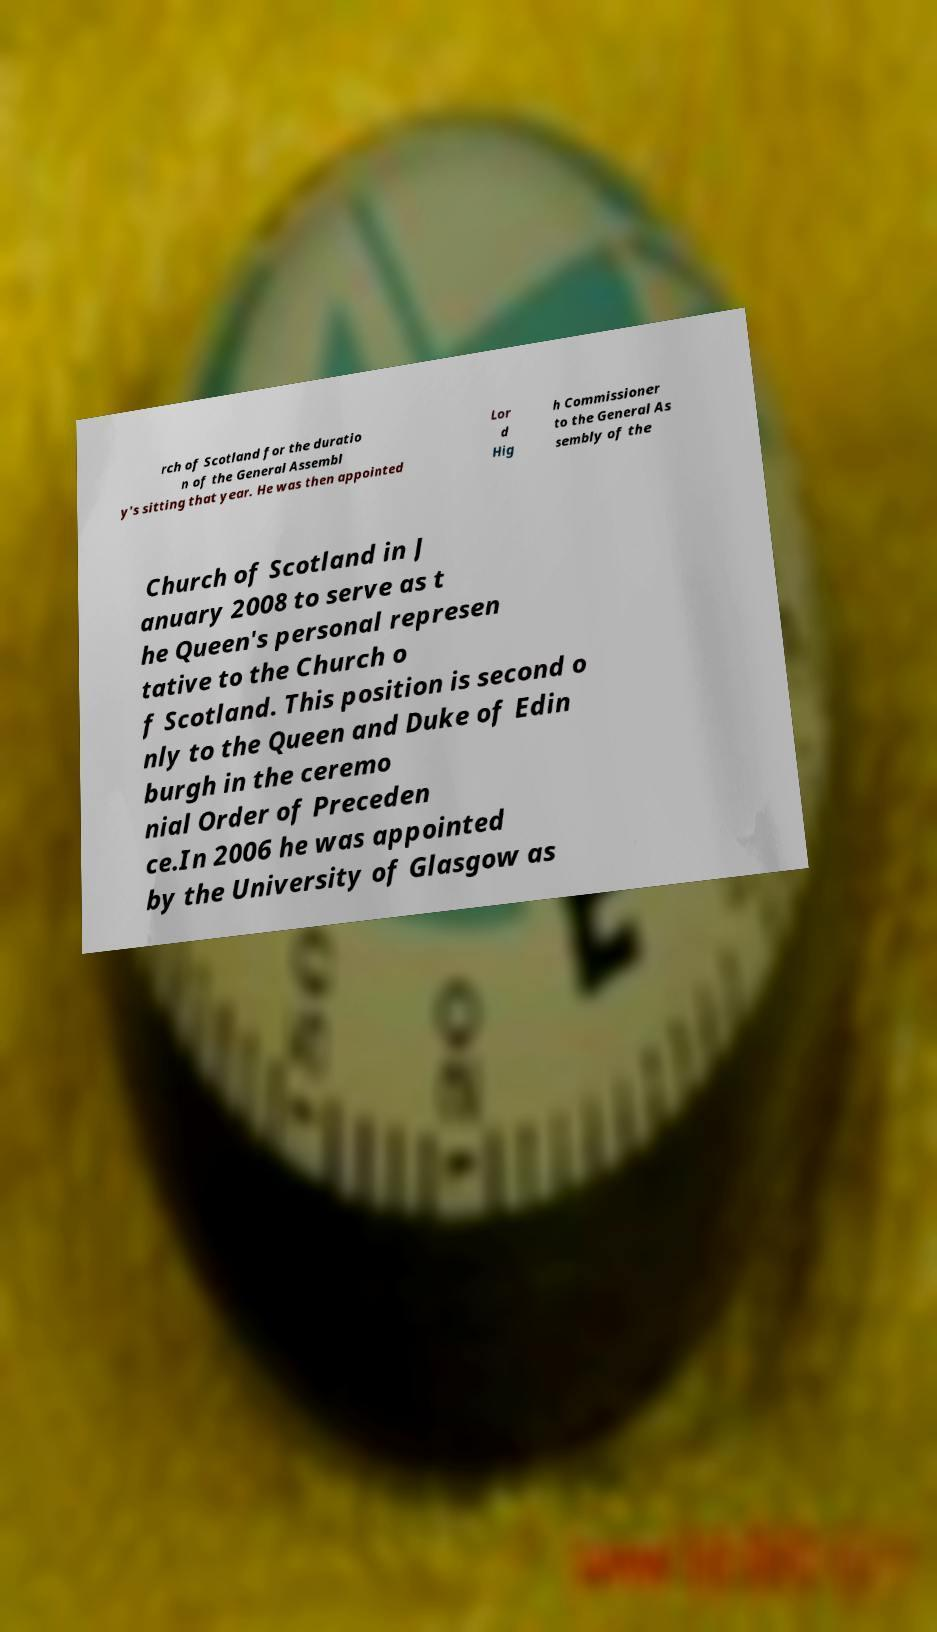Can you accurately transcribe the text from the provided image for me? rch of Scotland for the duratio n of the General Assembl y's sitting that year. He was then appointed Lor d Hig h Commissioner to the General As sembly of the Church of Scotland in J anuary 2008 to serve as t he Queen's personal represen tative to the Church o f Scotland. This position is second o nly to the Queen and Duke of Edin burgh in the ceremo nial Order of Preceden ce.In 2006 he was appointed by the University of Glasgow as 